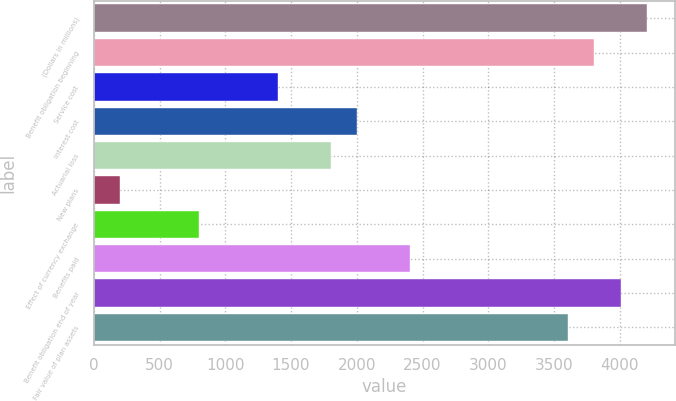Convert chart to OTSL. <chart><loc_0><loc_0><loc_500><loc_500><bar_chart><fcel>(Dollars in millions)<fcel>Benefit obligation beginning<fcel>Service cost<fcel>Interest cost<fcel>Actuarial loss<fcel>New plans<fcel>Effect of currency exchange<fcel>Benefits paid<fcel>Benefit obligation end of year<fcel>Fair value of plan assets<nl><fcel>4206.2<fcel>3805.8<fcel>1403.4<fcel>2004<fcel>1803.8<fcel>202.2<fcel>802.8<fcel>2404.4<fcel>4006<fcel>3605.6<nl></chart> 